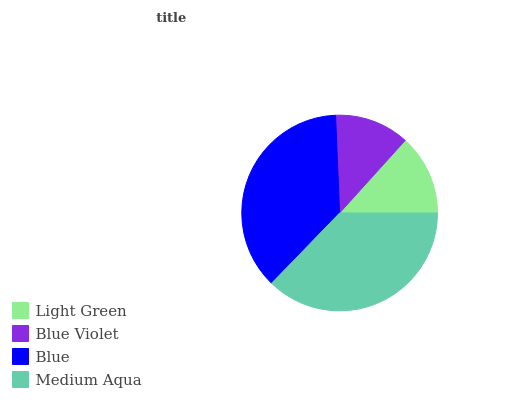Is Blue Violet the minimum?
Answer yes or no. Yes. Is Medium Aqua the maximum?
Answer yes or no. Yes. Is Blue the minimum?
Answer yes or no. No. Is Blue the maximum?
Answer yes or no. No. Is Blue greater than Blue Violet?
Answer yes or no. Yes. Is Blue Violet less than Blue?
Answer yes or no. Yes. Is Blue Violet greater than Blue?
Answer yes or no. No. Is Blue less than Blue Violet?
Answer yes or no. No. Is Blue the high median?
Answer yes or no. Yes. Is Light Green the low median?
Answer yes or no. Yes. Is Light Green the high median?
Answer yes or no. No. Is Blue Violet the low median?
Answer yes or no. No. 